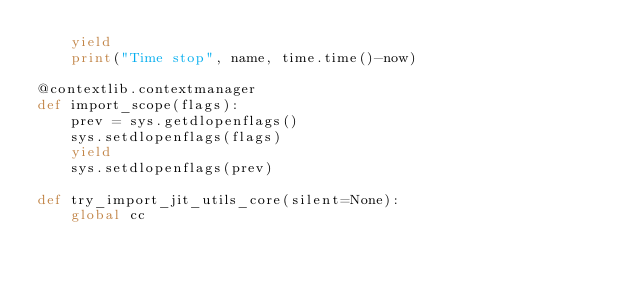Convert code to text. <code><loc_0><loc_0><loc_500><loc_500><_Python_>    yield
    print("Time stop", name, time.time()-now)

@contextlib.contextmanager
def import_scope(flags):
    prev = sys.getdlopenflags()
    sys.setdlopenflags(flags)
    yield
    sys.setdlopenflags(prev)

def try_import_jit_utils_core(silent=None):
    global cc</code> 